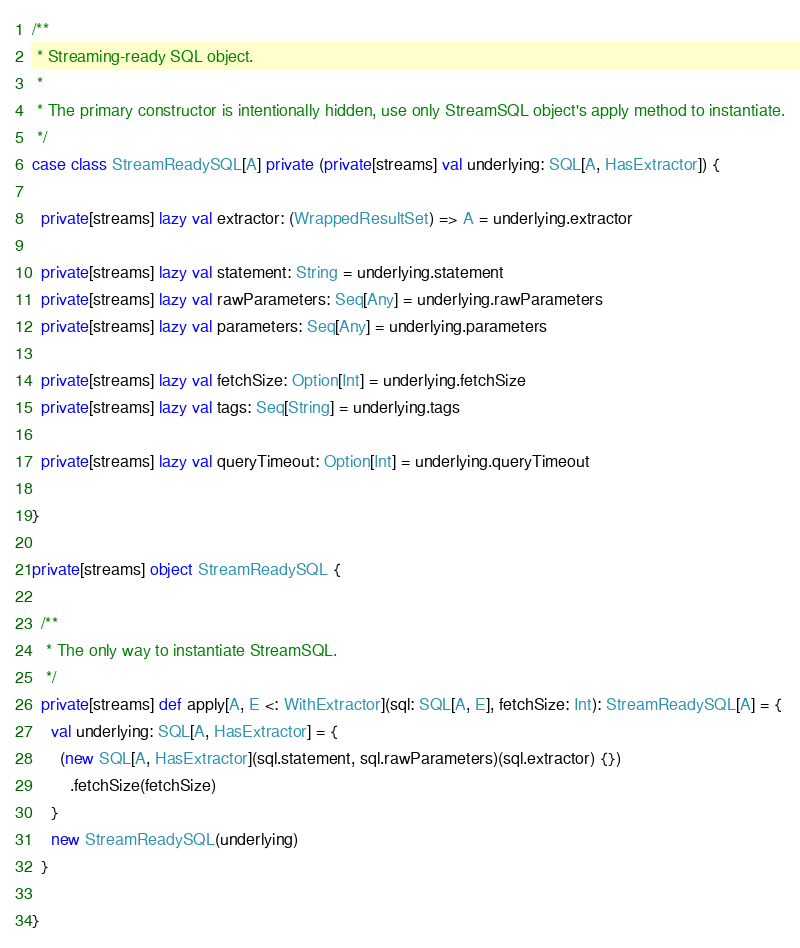<code> <loc_0><loc_0><loc_500><loc_500><_Scala_>
/**
 * Streaming-ready SQL object.
 *
 * The primary constructor is intentionally hidden, use only StreamSQL object's apply method to instantiate.
 */
case class StreamReadySQL[A] private (private[streams] val underlying: SQL[A, HasExtractor]) {

  private[streams] lazy val extractor: (WrappedResultSet) => A = underlying.extractor

  private[streams] lazy val statement: String = underlying.statement
  private[streams] lazy val rawParameters: Seq[Any] = underlying.rawParameters
  private[streams] lazy val parameters: Seq[Any] = underlying.parameters

  private[streams] lazy val fetchSize: Option[Int] = underlying.fetchSize
  private[streams] lazy val tags: Seq[String] = underlying.tags

  private[streams] lazy val queryTimeout: Option[Int] = underlying.queryTimeout

}

private[streams] object StreamReadySQL {

  /**
   * The only way to instantiate StreamSQL.
   */
  private[streams] def apply[A, E <: WithExtractor](sql: SQL[A, E], fetchSize: Int): StreamReadySQL[A] = {
    val underlying: SQL[A, HasExtractor] = {
      (new SQL[A, HasExtractor](sql.statement, sql.rawParameters)(sql.extractor) {})
        .fetchSize(fetchSize)
    }
    new StreamReadySQL(underlying)
  }

}
</code> 